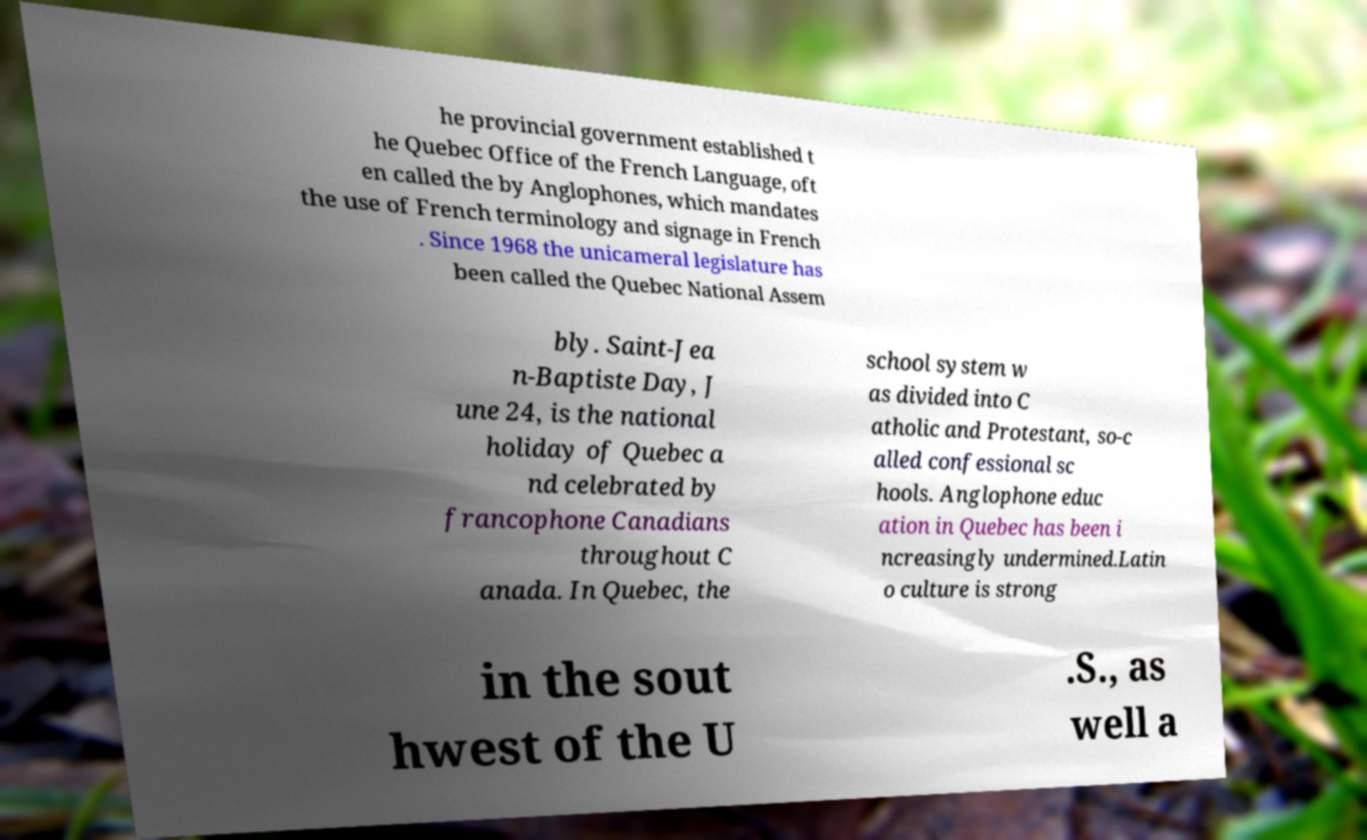Please read and relay the text visible in this image. What does it say? he provincial government established t he Quebec Office of the French Language, oft en called the by Anglophones, which mandates the use of French terminology and signage in French . Since 1968 the unicameral legislature has been called the Quebec National Assem bly. Saint-Jea n-Baptiste Day, J une 24, is the national holiday of Quebec a nd celebrated by francophone Canadians throughout C anada. In Quebec, the school system w as divided into C atholic and Protestant, so-c alled confessional sc hools. Anglophone educ ation in Quebec has been i ncreasingly undermined.Latin o culture is strong in the sout hwest of the U .S., as well a 